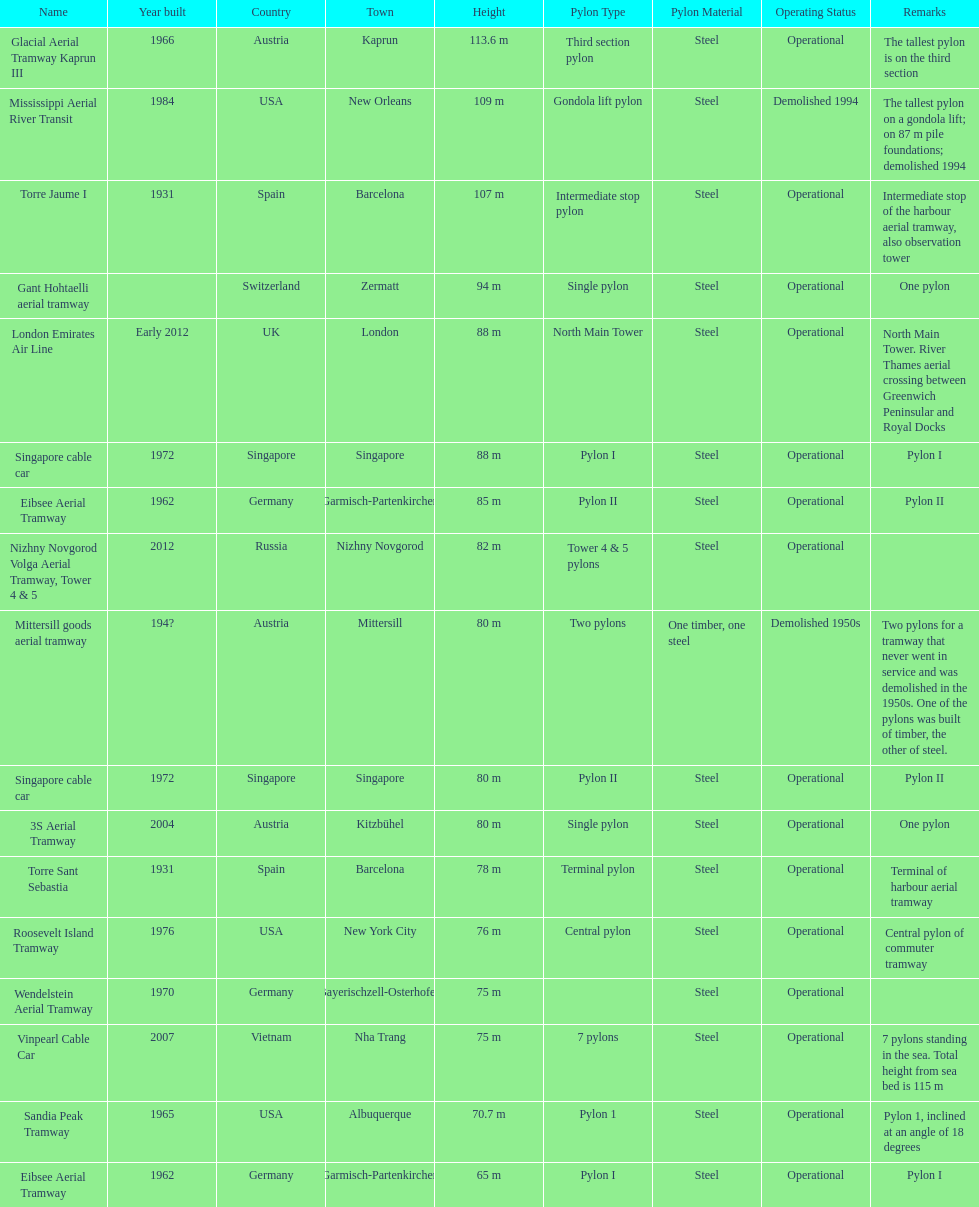I'm looking to parse the entire table for insights. Could you assist me with that? {'header': ['Name', 'Year built', 'Country', 'Town', 'Height', 'Pylon Type', 'Pylon Material', 'Operating Status', 'Remarks'], 'rows': [['Glacial Aerial Tramway Kaprun III', '1966', 'Austria', 'Kaprun', '113.6 m', 'Third section pylon', 'Steel', 'Operational', 'The tallest pylon is on the third section'], ['Mississippi Aerial River Transit', '1984', 'USA', 'New Orleans', '109 m', 'Gondola lift pylon', 'Steel', 'Demolished 1994', 'The tallest pylon on a gondola lift; on 87 m pile foundations; demolished 1994'], ['Torre Jaume I', '1931', 'Spain', 'Barcelona', '107 m', 'Intermediate stop pylon', 'Steel', 'Operational', 'Intermediate stop of the harbour aerial tramway, also observation tower'], ['Gant Hohtaelli aerial tramway', '', 'Switzerland', 'Zermatt', '94 m', 'Single pylon', 'Steel', 'Operational', 'One pylon'], ['London Emirates Air Line', 'Early 2012', 'UK', 'London', '88 m', 'North Main Tower', 'Steel', 'Operational', 'North Main Tower. River Thames aerial crossing between Greenwich Peninsular and Royal Docks'], ['Singapore cable car', '1972', 'Singapore', 'Singapore', '88 m', 'Pylon I', 'Steel', 'Operational', 'Pylon I'], ['Eibsee Aerial Tramway', '1962', 'Germany', 'Garmisch-Partenkirchen', '85 m', 'Pylon II', 'Steel', 'Operational', 'Pylon II'], ['Nizhny Novgorod Volga Aerial Tramway, Tower 4 & 5', '2012', 'Russia', 'Nizhny Novgorod', '82 m', 'Tower 4 & 5 pylons', 'Steel', 'Operational', ''], ['Mittersill goods aerial tramway', '194?', 'Austria', 'Mittersill', '80 m', 'Two pylons', 'One timber, one steel', 'Demolished 1950s', 'Two pylons for a tramway that never went in service and was demolished in the 1950s. One of the pylons was built of timber, the other of steel.'], ['Singapore cable car', '1972', 'Singapore', 'Singapore', '80 m', 'Pylon II', 'Steel', 'Operational', 'Pylon II'], ['3S Aerial Tramway', '2004', 'Austria', 'Kitzbühel', '80 m', 'Single pylon', 'Steel', 'Operational', 'One pylon'], ['Torre Sant Sebastia', '1931', 'Spain', 'Barcelona', '78 m', 'Terminal pylon', 'Steel', 'Operational', 'Terminal of harbour aerial tramway'], ['Roosevelt Island Tramway', '1976', 'USA', 'New York City', '76 m', 'Central pylon', 'Steel', 'Operational', 'Central pylon of commuter tramway'], ['Wendelstein Aerial Tramway', '1970', 'Germany', 'Bayerischzell-Osterhofen', '75 m', '', 'Steel', 'Operational', ''], ['Vinpearl Cable Car', '2007', 'Vietnam', 'Nha Trang', '75 m', '7 pylons', 'Steel', 'Operational', '7 pylons standing in the sea. Total height from sea bed is 115 m'], ['Sandia Peak Tramway', '1965', 'USA', 'Albuquerque', '70.7 m', 'Pylon 1', 'Steel', 'Operational', 'Pylon 1, inclined at an angle of 18 degrees'], ['Eibsee Aerial Tramway', '1962', 'Germany', 'Garmisch-Partenkirchen', '65 m', 'Pylon I', 'Steel', 'Operational', 'Pylon I']]} Which pylon has the most remarks about it? Mittersill goods aerial tramway. 